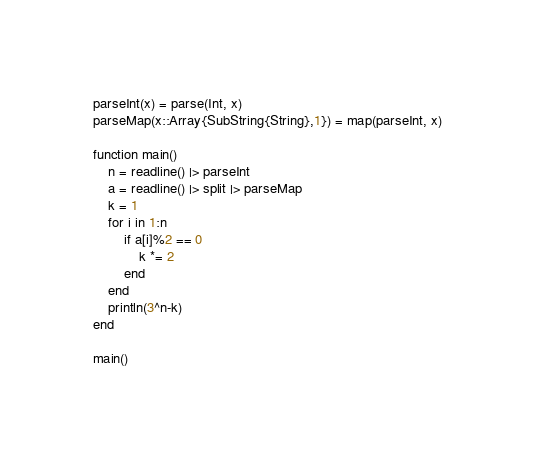Convert code to text. <code><loc_0><loc_0><loc_500><loc_500><_Julia_>parseInt(x) = parse(Int, x)
parseMap(x::Array{SubString{String},1}) = map(parseInt, x)

function main()
	n = readline() |> parseInt
	a = readline() |> split |> parseMap
	k = 1
	for i in 1:n
		if a[i]%2 == 0
			k *= 2
		end
	end
	println(3^n-k)
end

main()</code> 